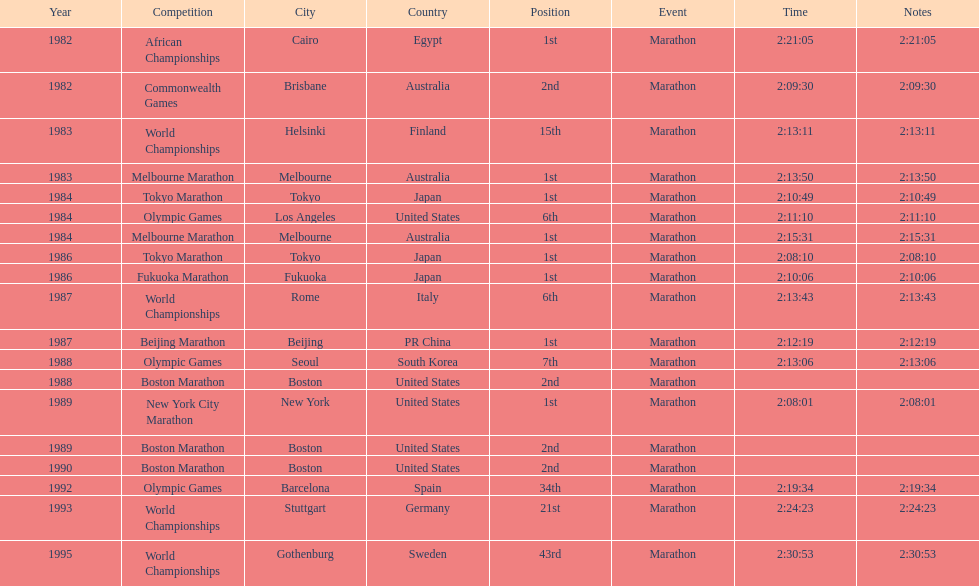What are the competitions? African Championships, Cairo, Egypt, Commonwealth Games, Brisbane, Australia, World Championships, Helsinki, Finland, Melbourne Marathon, Melbourne, Australia, Tokyo Marathon, Tokyo, Japan, Olympic Games, Los Angeles, United States, Melbourne Marathon, Melbourne, Australia, Tokyo Marathon, Tokyo, Japan, Fukuoka Marathon, Fukuoka, Japan, World Championships, Rome, Italy, Beijing Marathon, Beijing, PR China, Olympic Games, Seoul, South Korea, Boston Marathon, Boston, United States, New York City Marathon, New York, United States, Boston Marathon, Boston, United States, Boston Marathon, Boston, United States, Olympic Games, Barcelona, Spain, World Championships, Stuttgart, Germany, World Championships, Gothenburg, Sweden. Which ones occured in china? Beijing Marathon, Beijing, PR China. Which one is it? Beijing Marathon. 